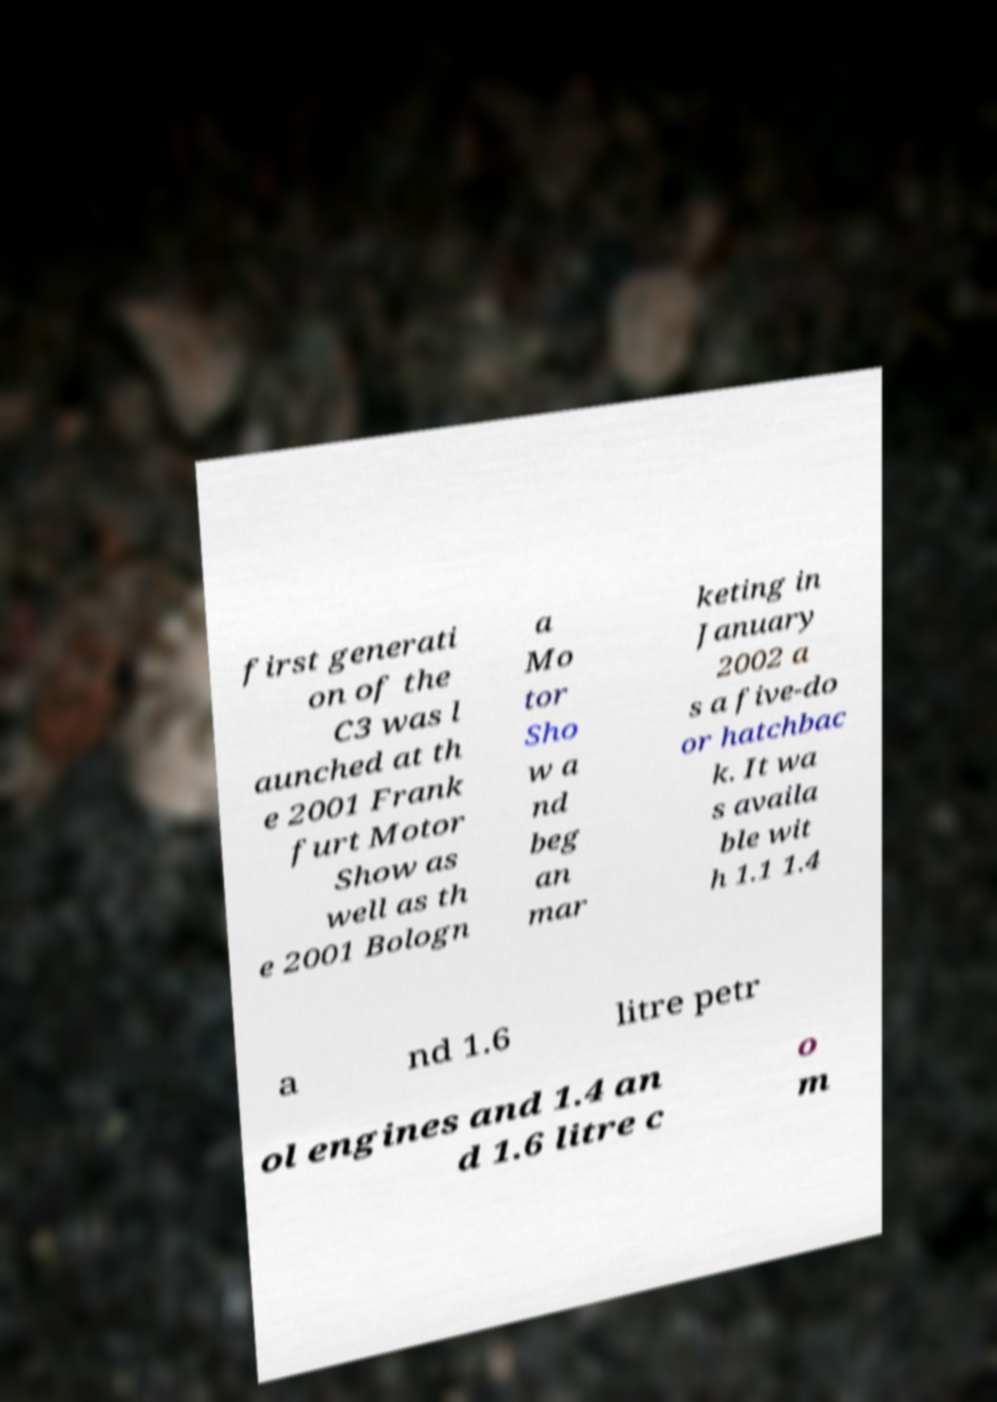There's text embedded in this image that I need extracted. Can you transcribe it verbatim? first generati on of the C3 was l aunched at th e 2001 Frank furt Motor Show as well as th e 2001 Bologn a Mo tor Sho w a nd beg an mar keting in January 2002 a s a five-do or hatchbac k. It wa s availa ble wit h 1.1 1.4 a nd 1.6 litre petr ol engines and 1.4 an d 1.6 litre c o m 